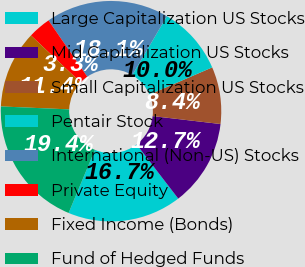Convert chart. <chart><loc_0><loc_0><loc_500><loc_500><pie_chart><fcel>Large Capitalization US Stocks<fcel>Mid Capitalization US Stocks<fcel>Small Capitalization US Stocks<fcel>Pentair Stock<fcel>International (Non-US) Stocks<fcel>Private Equity<fcel>Fixed Income (Bonds)<fcel>Fund of Hedged Funds<nl><fcel>16.72%<fcel>12.71%<fcel>8.36%<fcel>10.03%<fcel>18.06%<fcel>3.34%<fcel>11.37%<fcel>19.4%<nl></chart> 